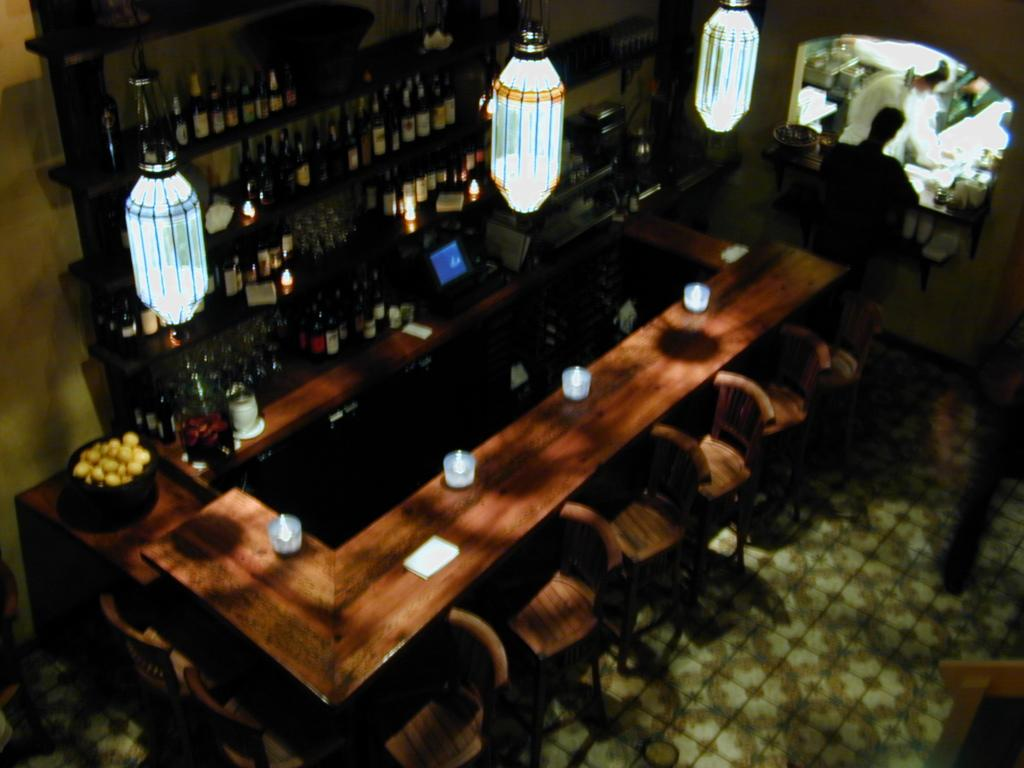What can be seen in the racks in the image? There are bottles in the racks in the image. What is on the table in the image? There are objects on the table in the image. What type of lighting is present in the image? There are lights hanging in the image. What type of furniture is visible in the image? There are chairs in the image. Are there any people present in the image? Yes, there are people in the image. Can you tell me how many robins are sitting on the chairs in the image? There are no robins present in the image; it features bottles, objects, lights, chairs, and people. What type of shade is provided by the lights in the image? The lights in the image are hanging, not providing any shade. 